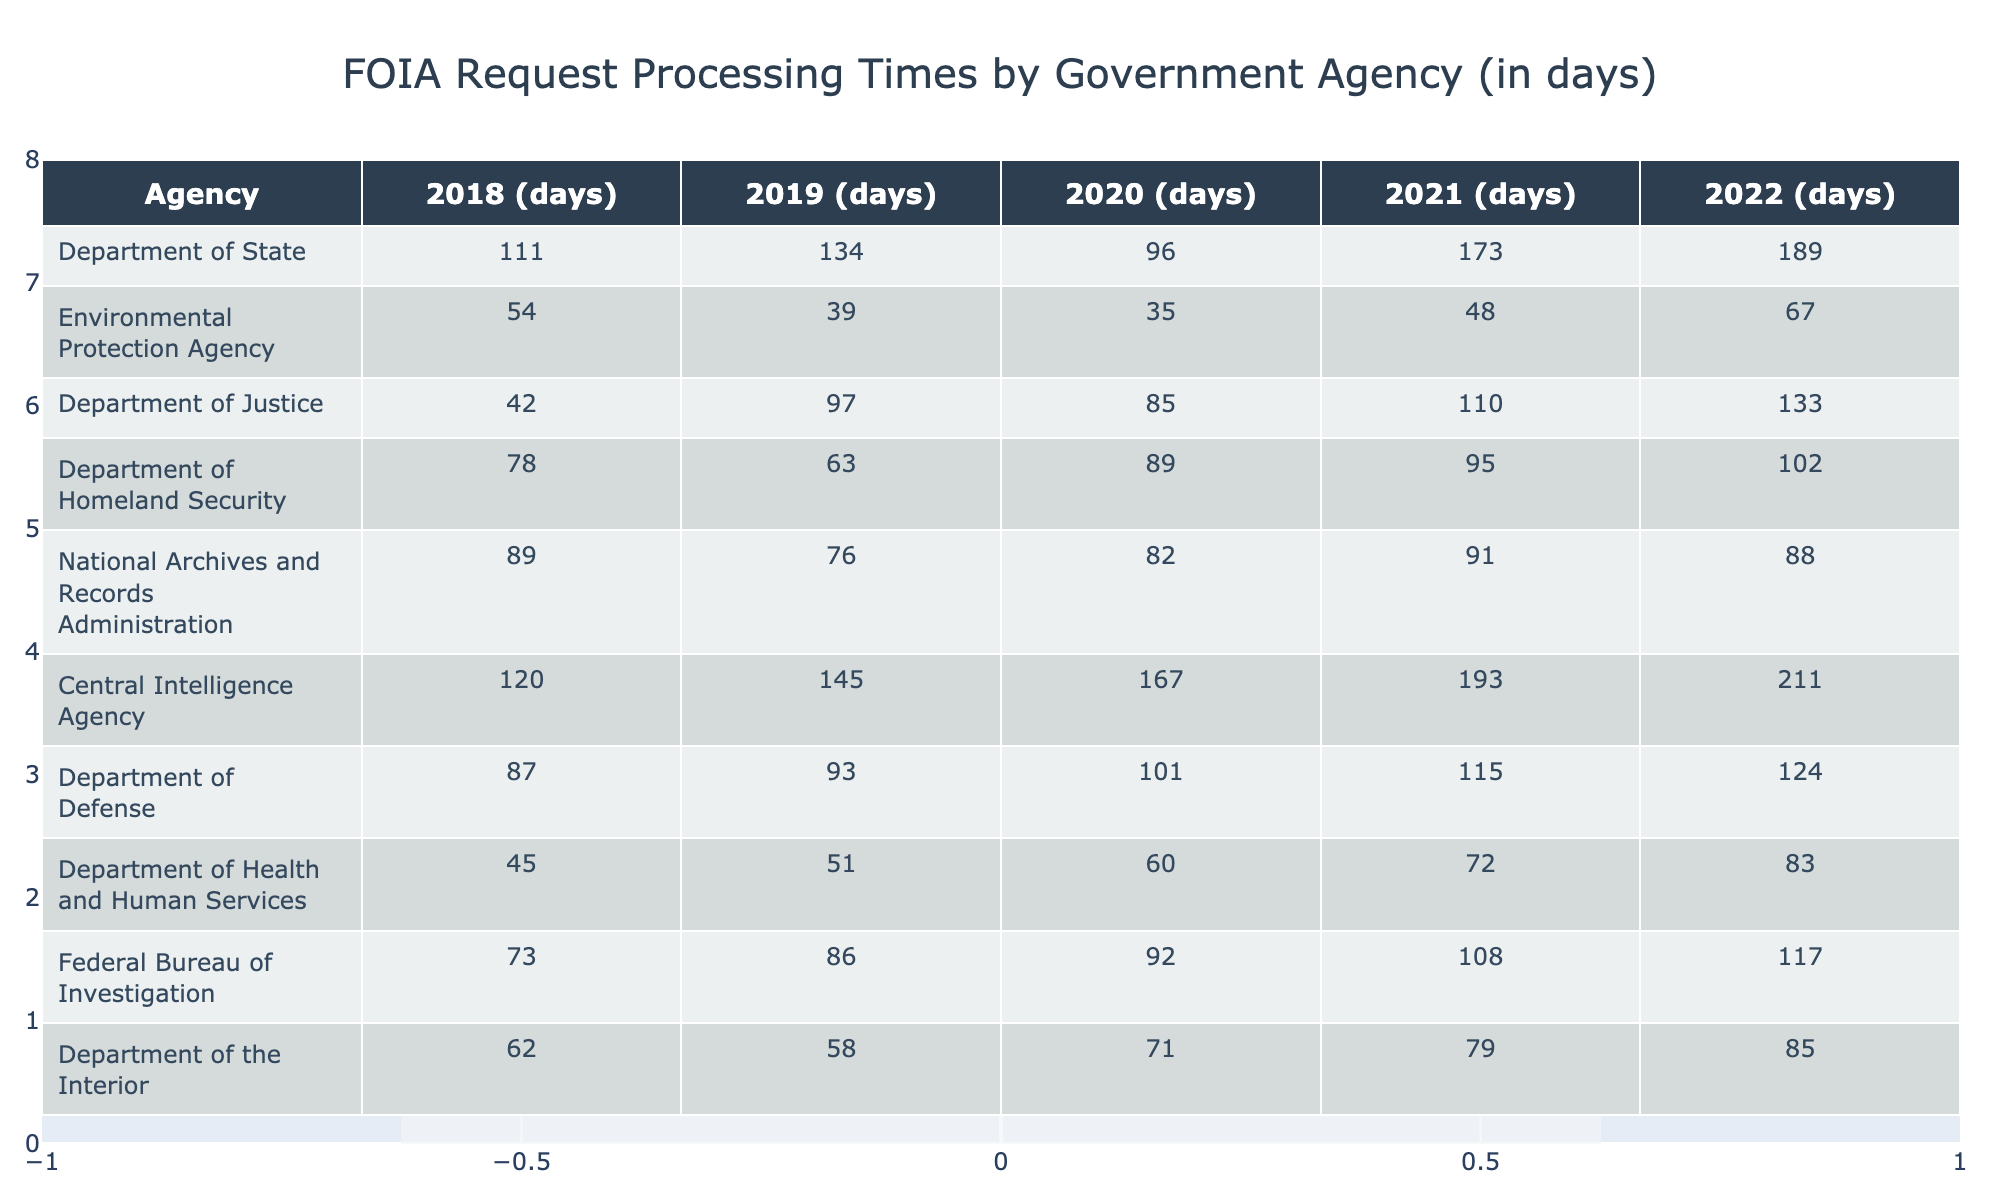What is the longest processing time recorded in 2022? In 2022, the Department of State has the highest processing time of 189 days, which is more than any other agency listed.
Answer: 189 days Which agency had the shortest processing time in 2019? The Environmental Protection Agency processed requests in only 39 days in 2019, making it the agency with the shortest processing time that year.
Answer: 39 days Did the Federal Bureau of Investigation improve its processing time from 2018 to 2019? In 2018, the FBI had a processing time of 73 days, which increased to 86 days in 2019, indicating a decline in request processing efficiency.
Answer: No What was the average processing time for the Department of Defense from 2018 to 2022? The processing times for the Department of Defense over these years are 87, 93, 101, 115, and 124. The average is calculated as (87 + 93 + 101 + 115 + 124) / 5 = 104
Answer: 104 days Which agency showed the most significant increase in processing time from 2020 to 2021? The Central Intelligence Agency went from 167 days in 2020 to 193 days in 2021, an increase of 26 days, which is the most significant rise among all agencies from these years.
Answer: Central Intelligence Agency What year did the Department of Health and Human Services have the lowest processing time? The Department of Health and Human Services had the lowest processing time of 45 days in 2018 compared to subsequent years.
Answer: 2018 How many agencies had a processing time of over 100 days in 2022? The agencies with processing times over 100 days in 2022 include the Department of State, Department of Justice, Department of Homeland Security, and Central Intelligence Agency, totaling four agencies.
Answer: 4 agencies If you sum the processing times for the Environmental Protection Agency from 2018 to 2022, what is the total? The processing times are 54, 39, 35, 48, and 67. Summing these gives 54 + 39 + 35 + 48 + 67 = 243 days.
Answer: 243 days What trend can be observed in the processing times of the Department of State from 2018 to 2022? The processing times showed a fluctuating trend, starting at 111 days in 2018, decreasing to 96 days in 2020, followed by an increase to 173 days in 2021, and ending at 189 days in 2022.
Answer: Fluctuating trend Which agency processed requests the fastest on average during the years recorded? The Environmental Protection Agency had consistently lower processing times averaging 48.6 days over the five years, making it the fastest agency overall.
Answer: Environmental Protection Agency 